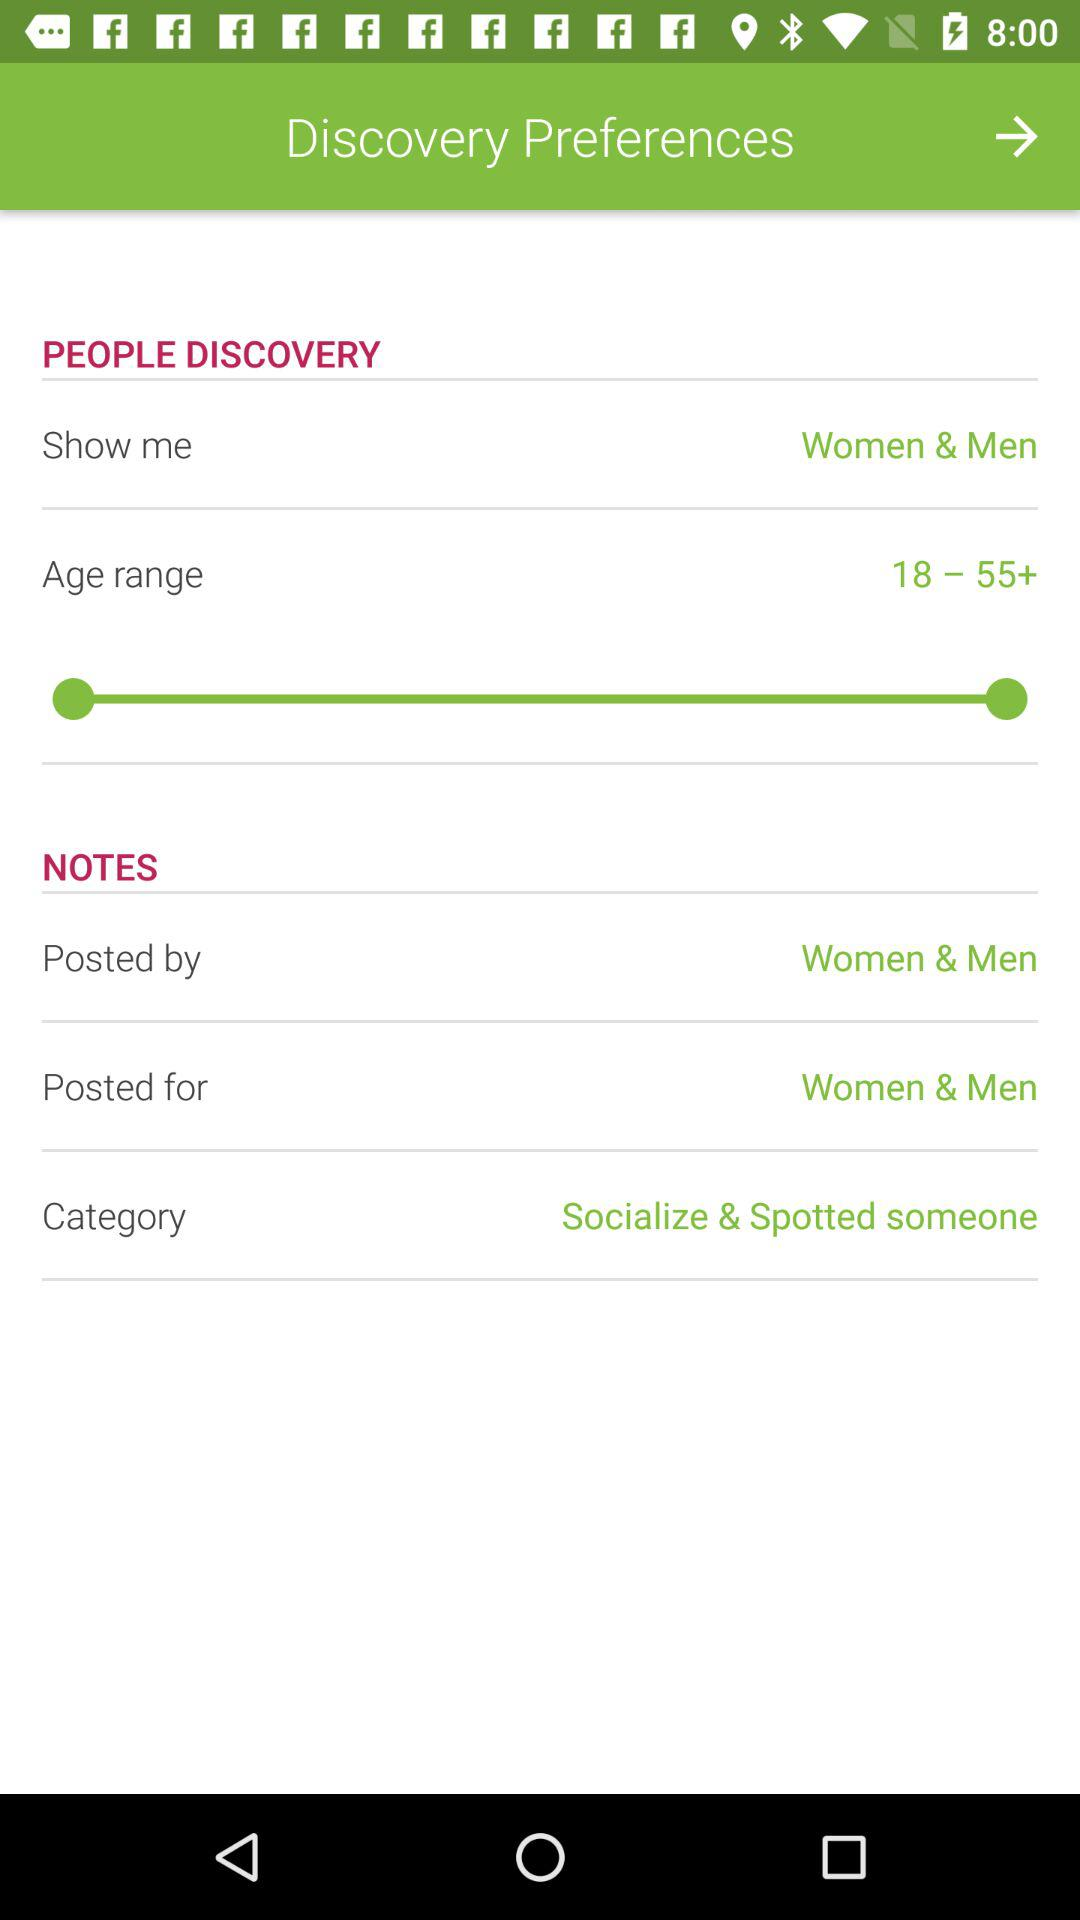Is "NOTES" on or off?
When the provided information is insufficient, respond with <no answer>. <no answer> 